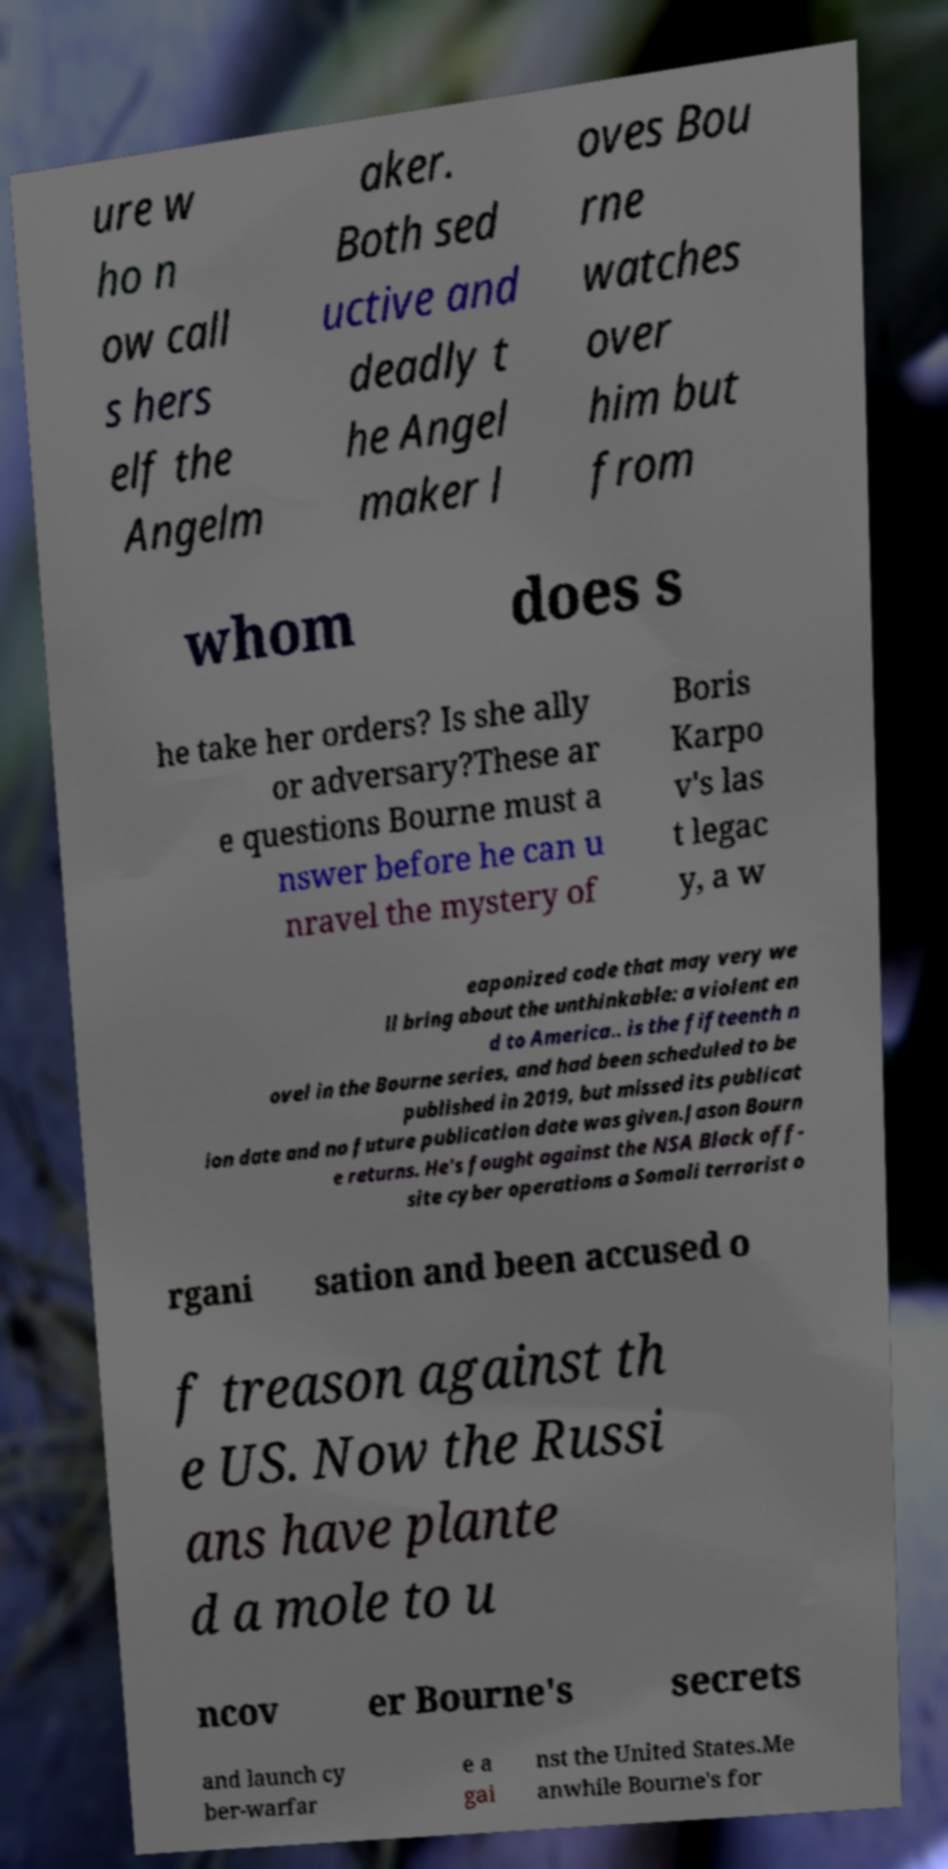Please read and relay the text visible in this image. What does it say? ure w ho n ow call s hers elf the Angelm aker. Both sed uctive and deadly t he Angel maker l oves Bou rne watches over him but from whom does s he take her orders? Is she ally or adversary?These ar e questions Bourne must a nswer before he can u nravel the mystery of Boris Karpo v's las t legac y, a w eaponized code that may very we ll bring about the unthinkable: a violent en d to America.. is the fifteenth n ovel in the Bourne series, and had been scheduled to be published in 2019, but missed its publicat ion date and no future publication date was given.Jason Bourn e returns. He's fought against the NSA Black off- site cyber operations a Somali terrorist o rgani sation and been accused o f treason against th e US. Now the Russi ans have plante d a mole to u ncov er Bourne's secrets and launch cy ber-warfar e a gai nst the United States.Me anwhile Bourne's for 